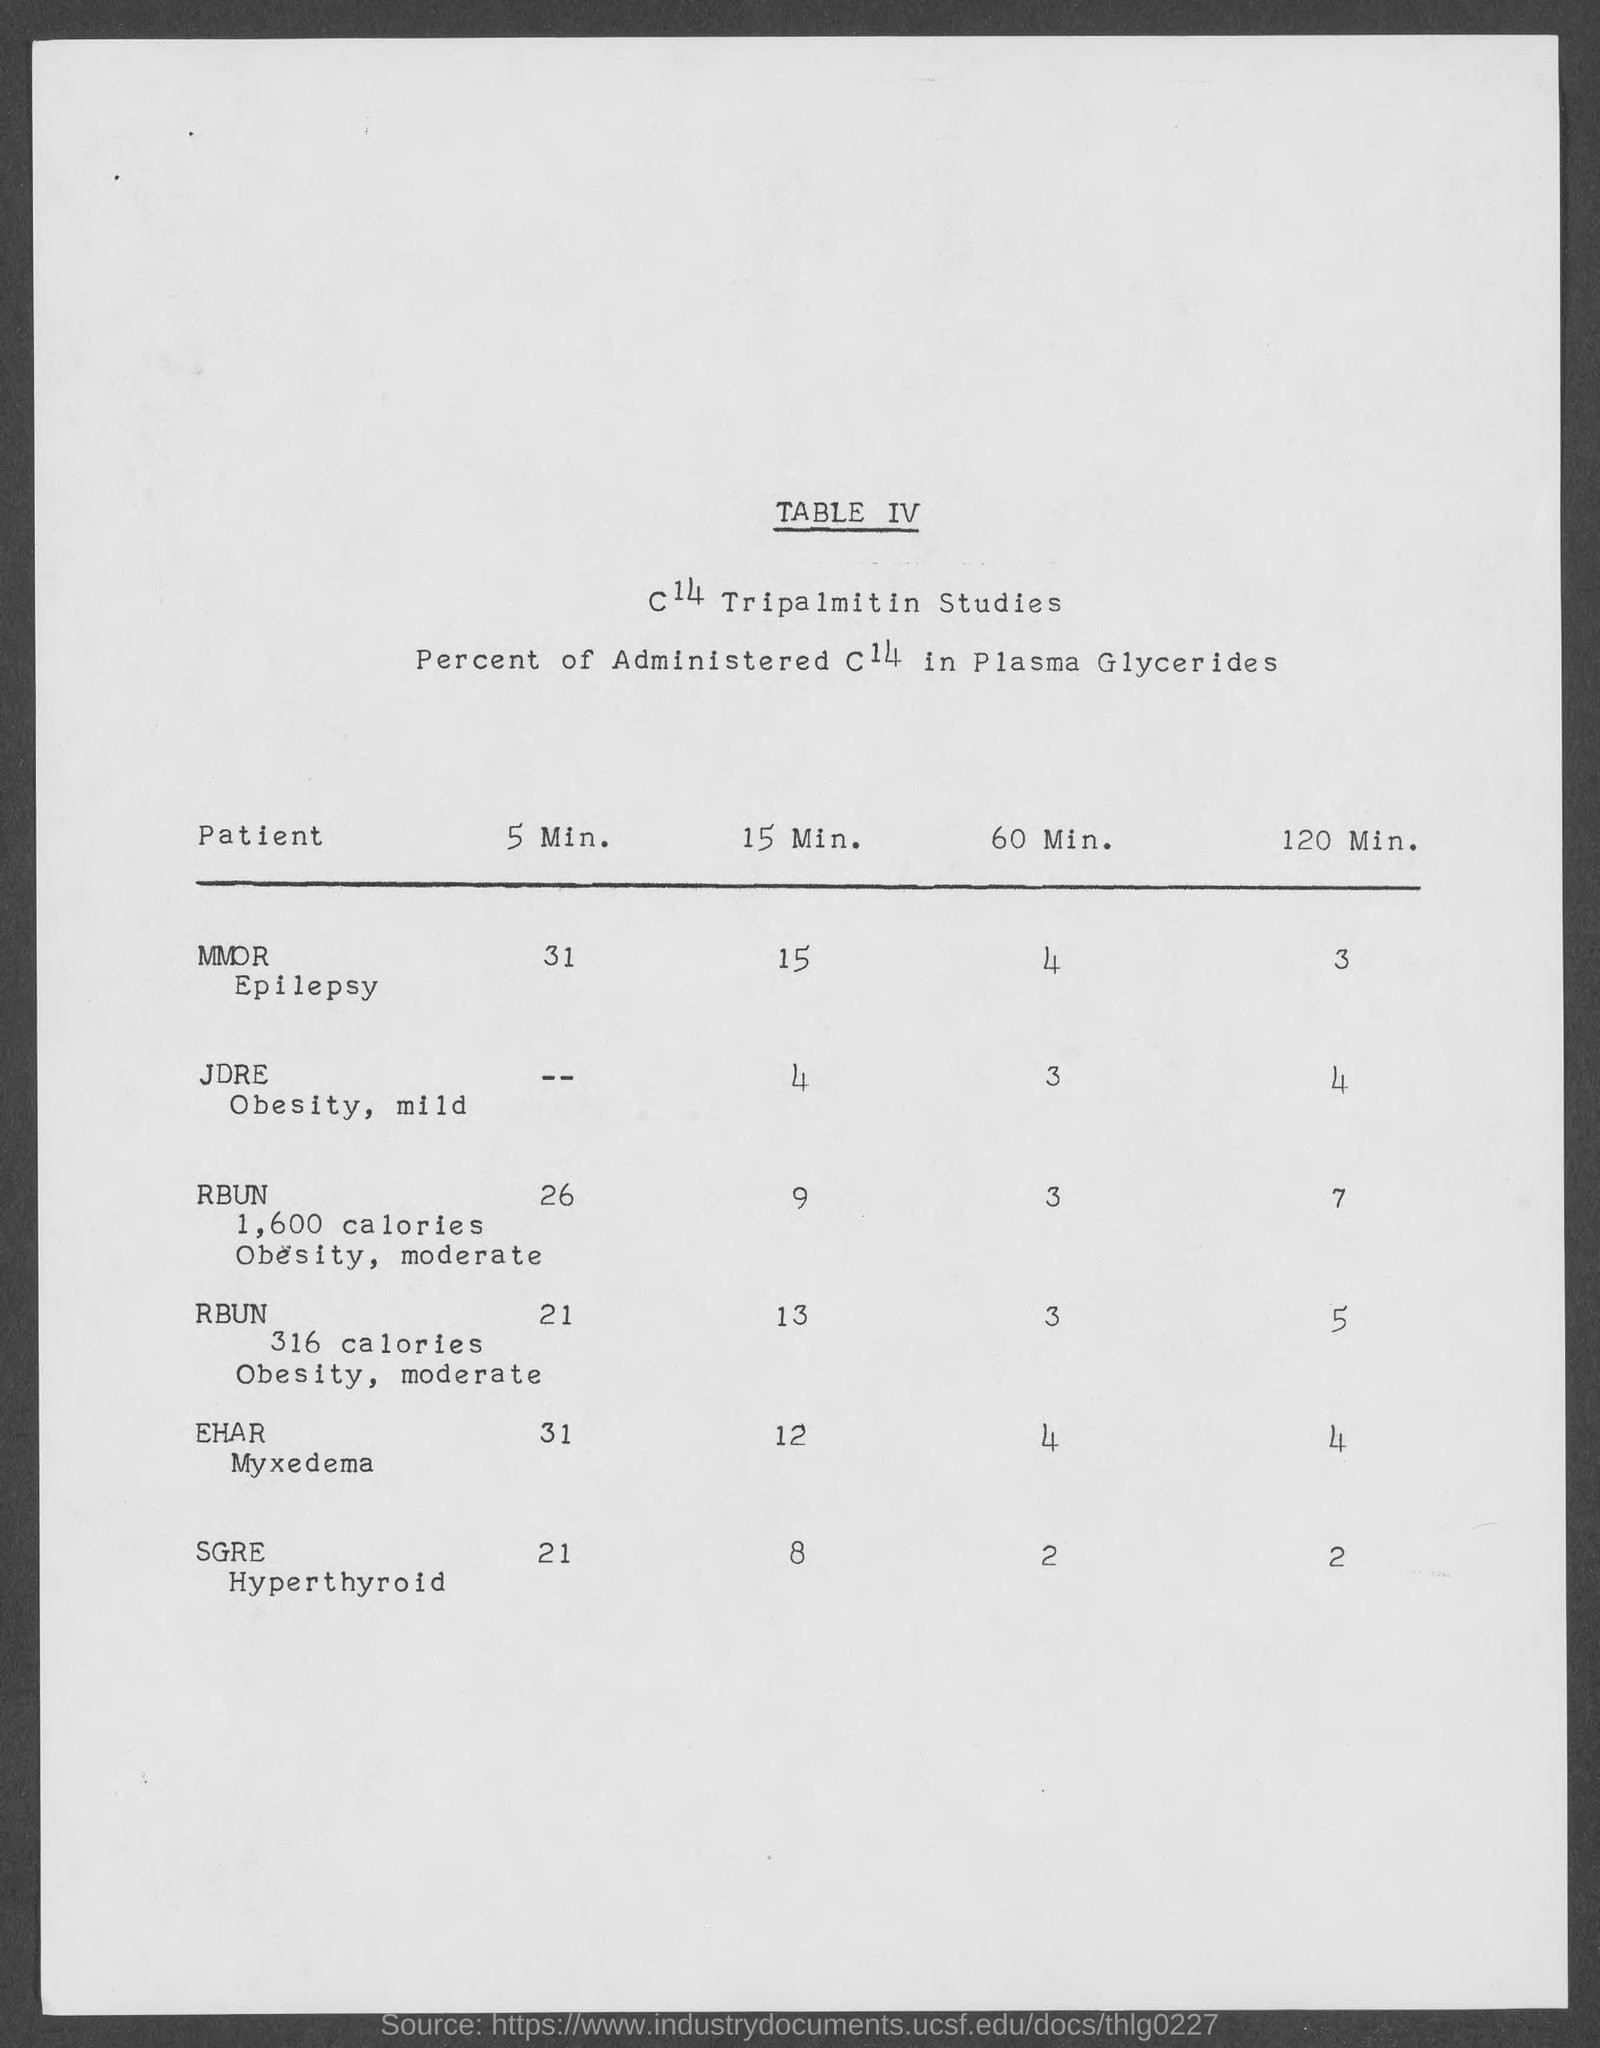Mention a couple of crucial points in this snapshot. The administered C14 concentration in plasma glycerides in an EHAR myxedema patient after 60 minutes is [value]. What is the percentage of administered C14 in plasma glycerides in an EHAR myxedema patient within 5 minutes? The administered C14 in plasma glycerides of an MMOR Epilepsy patient was measured in the 120-minute time frame. The administered C14 in plasma glycerides in JDRE Obesity, a mild patient, was 4% in 15 minutes. The administered C14 in plasma glycerides of a mild JDRE Obesity patient in 60 minutes is (3). 